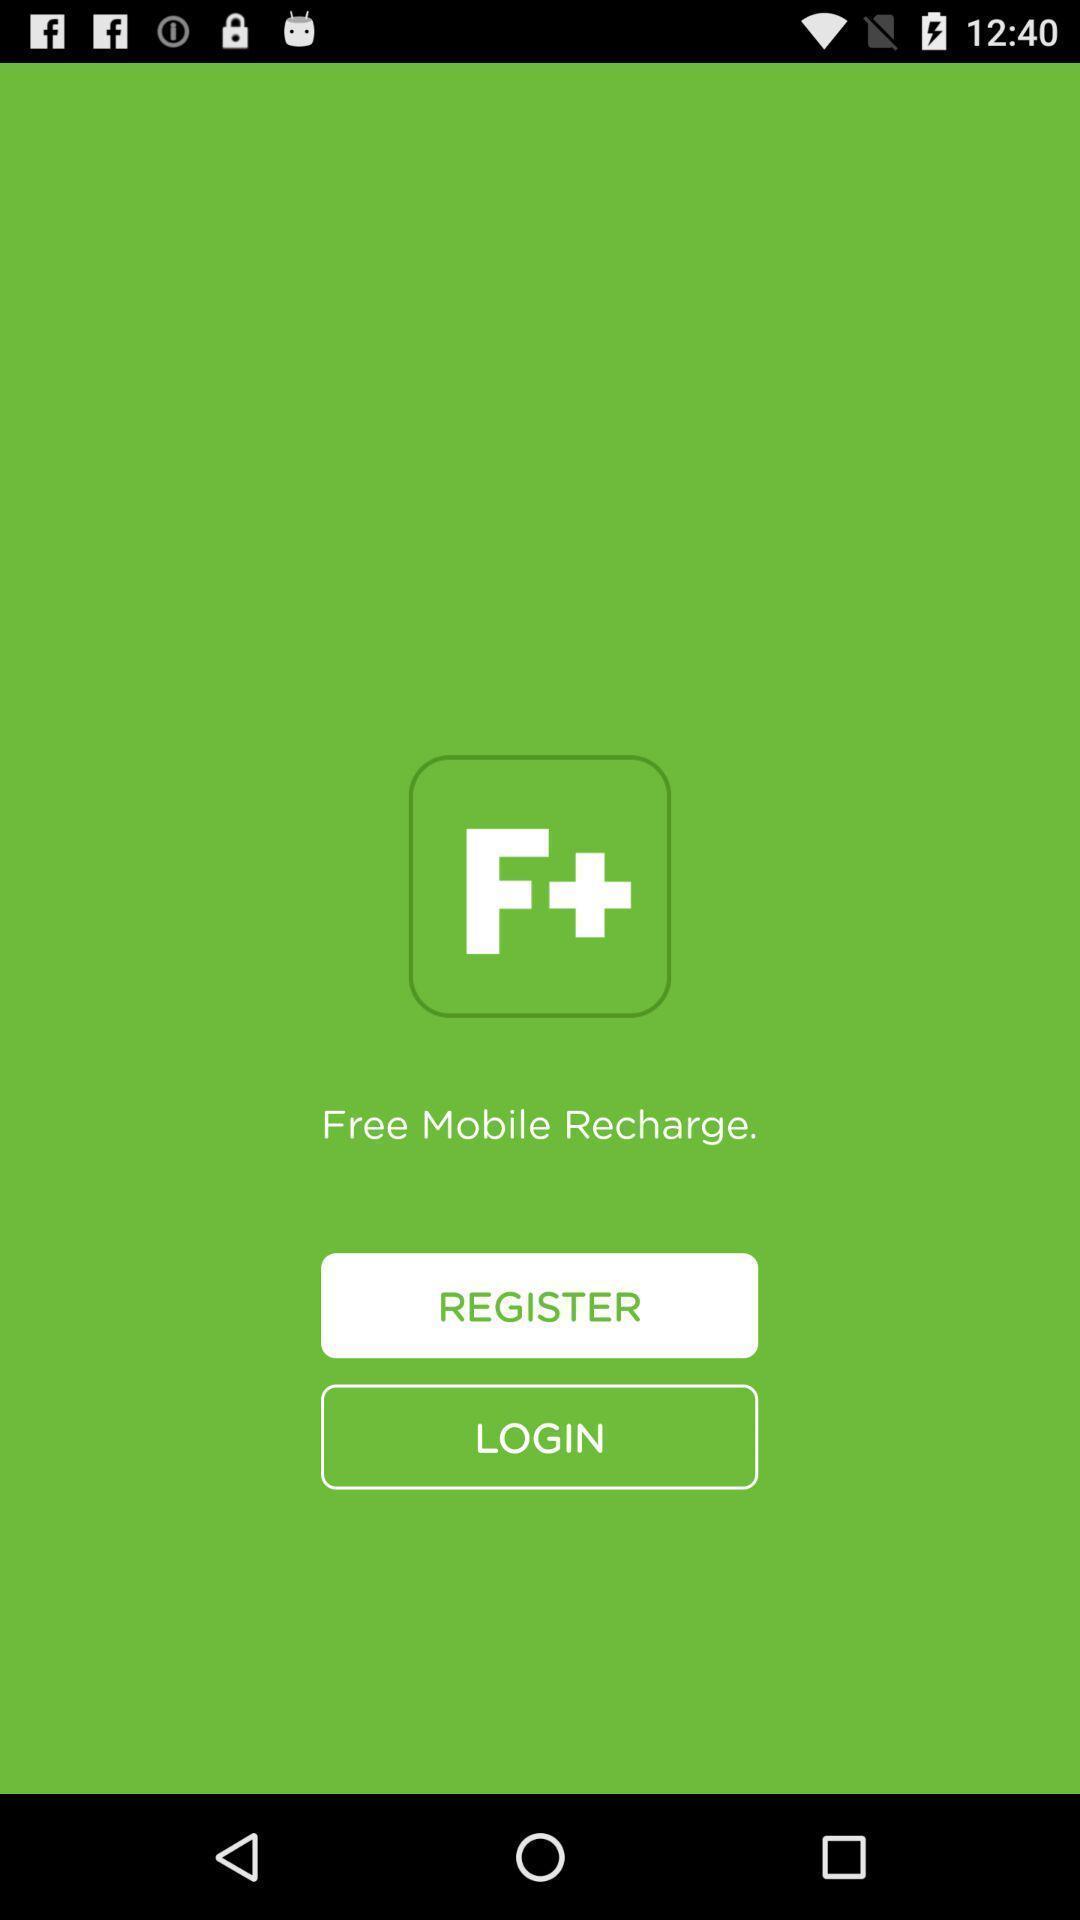Summarize the main components in this picture. Sign up page for the payment app. 